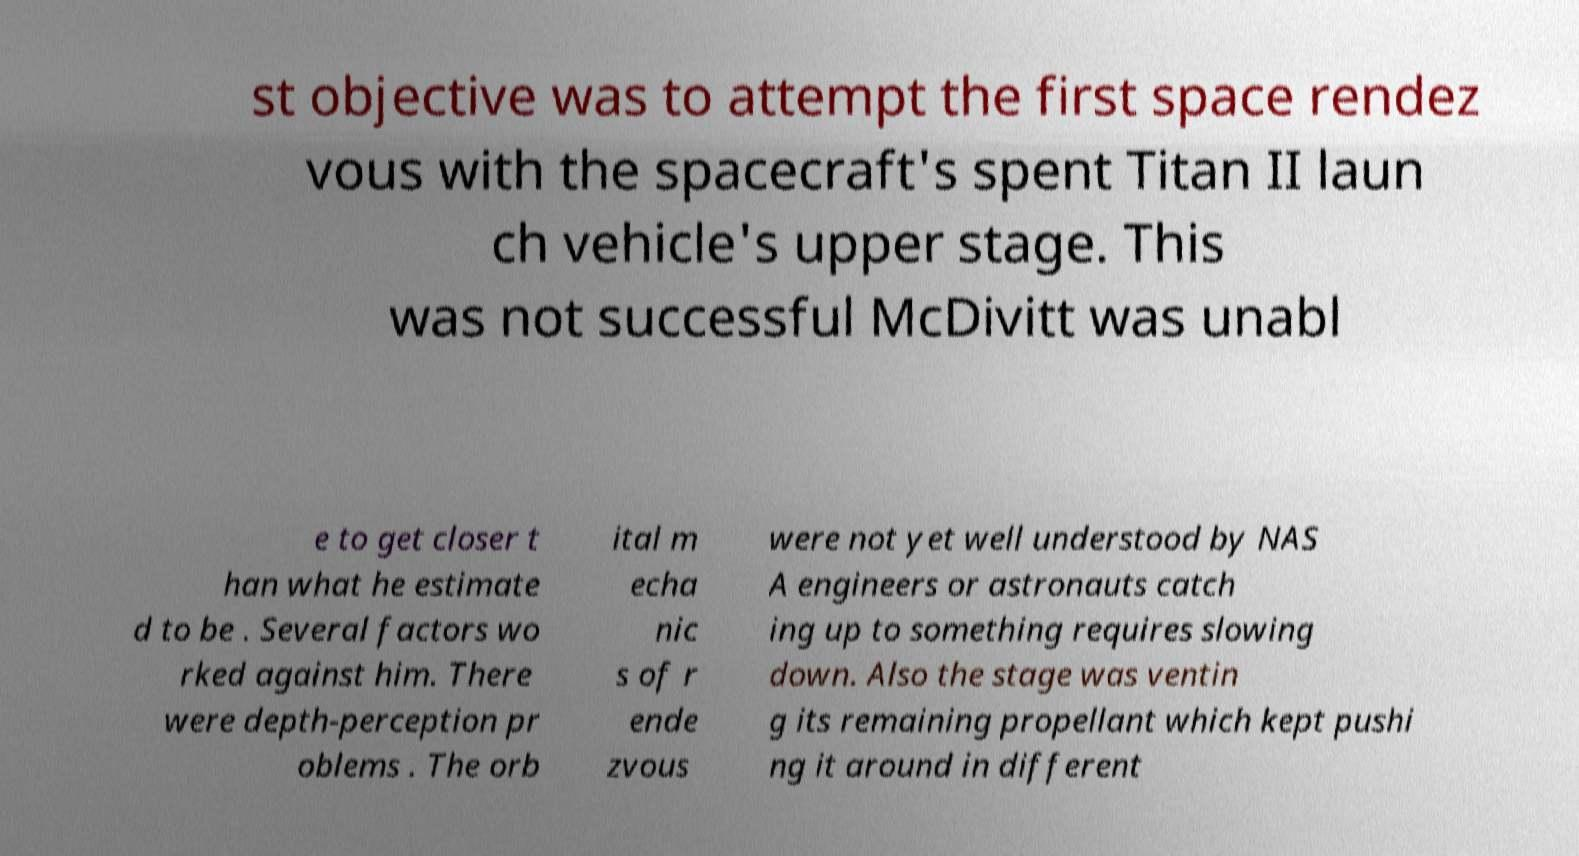Please read and relay the text visible in this image. What does it say? st objective was to attempt the first space rendez vous with the spacecraft's spent Titan II laun ch vehicle's upper stage. This was not successful McDivitt was unabl e to get closer t han what he estimate d to be . Several factors wo rked against him. There were depth-perception pr oblems . The orb ital m echa nic s of r ende zvous were not yet well understood by NAS A engineers or astronauts catch ing up to something requires slowing down. Also the stage was ventin g its remaining propellant which kept pushi ng it around in different 